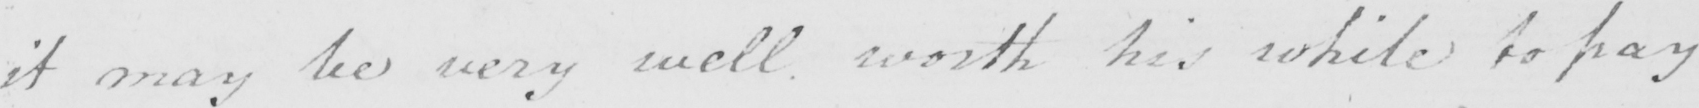What text is written in this handwritten line? it may be very well worth his while to pay 